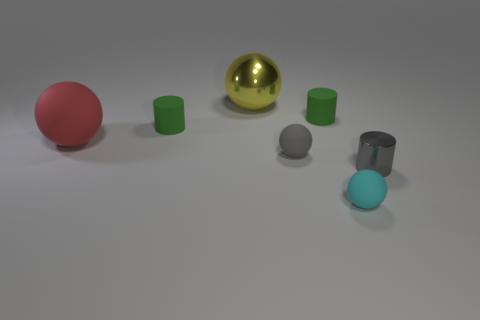What number of things are either large balls behind the big red rubber sphere or rubber balls on the left side of the cyan thing?
Offer a terse response. 3. Are there fewer tiny rubber cylinders than large red rubber balls?
Your response must be concise. No. There is a yellow object; are there any gray objects behind it?
Offer a terse response. No. Are the yellow object and the small gray cylinder made of the same material?
Provide a short and direct response. Yes. What color is the large rubber thing that is the same shape as the tiny cyan matte thing?
Your answer should be very brief. Red. There is a shiny object behind the gray metallic cylinder; is it the same color as the tiny shiny cylinder?
Make the answer very short. No. What number of other things have the same material as the large red thing?
Your answer should be very brief. 4. How many large red spheres are to the left of the tiny cyan rubber object?
Your response must be concise. 1. What size is the cyan thing?
Your answer should be compact. Small. There is a ball that is the same size as the cyan rubber thing; what color is it?
Give a very brief answer. Gray. 